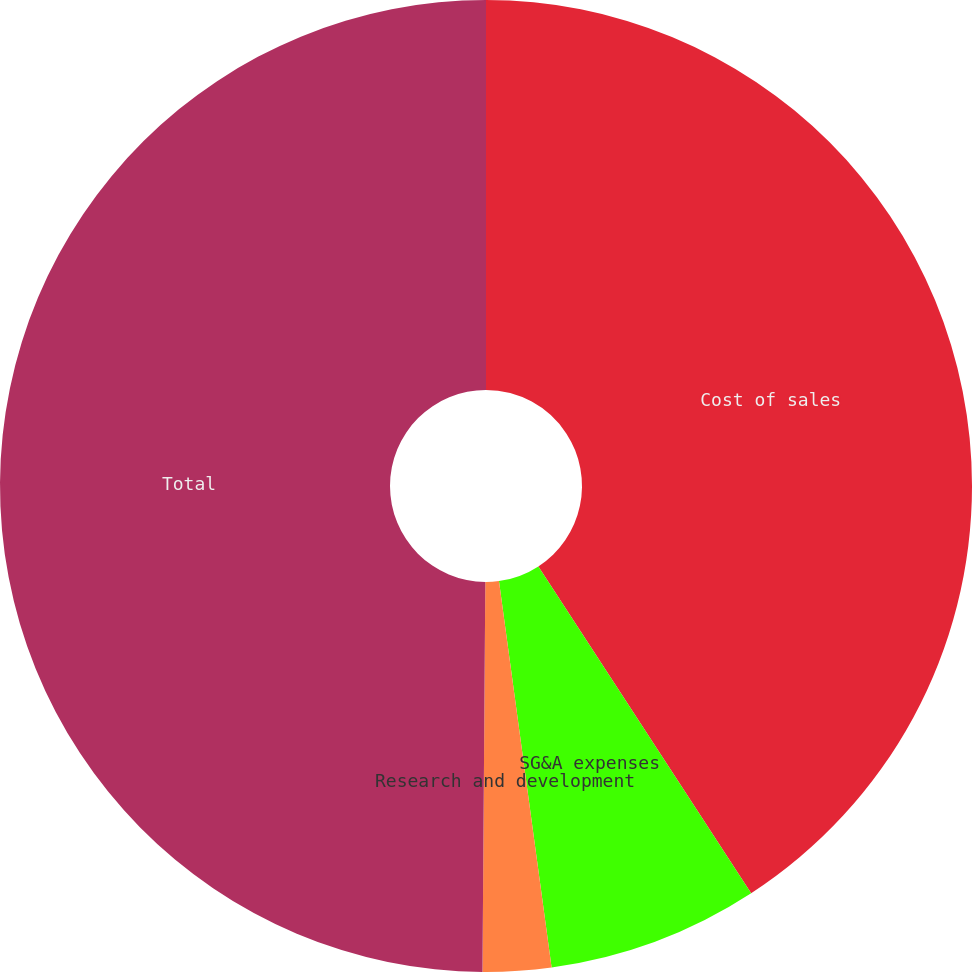<chart> <loc_0><loc_0><loc_500><loc_500><pie_chart><fcel>Cost of sales<fcel>SG&A expenses<fcel>Research and development<fcel>Total<nl><fcel>40.82%<fcel>7.03%<fcel>2.27%<fcel>49.89%<nl></chart> 